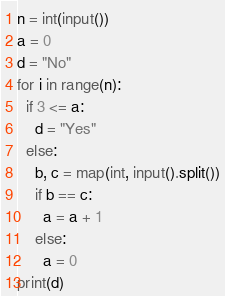<code> <loc_0><loc_0><loc_500><loc_500><_Python_>n = int(input())
a = 0
d = "No"
for i in range(n):
  if 3 <= a:
    d = "Yes"
  else:
    b, c = map(int, input().split())
    if b == c:
      a = a + 1
    else:
      a = 0
print(d)</code> 